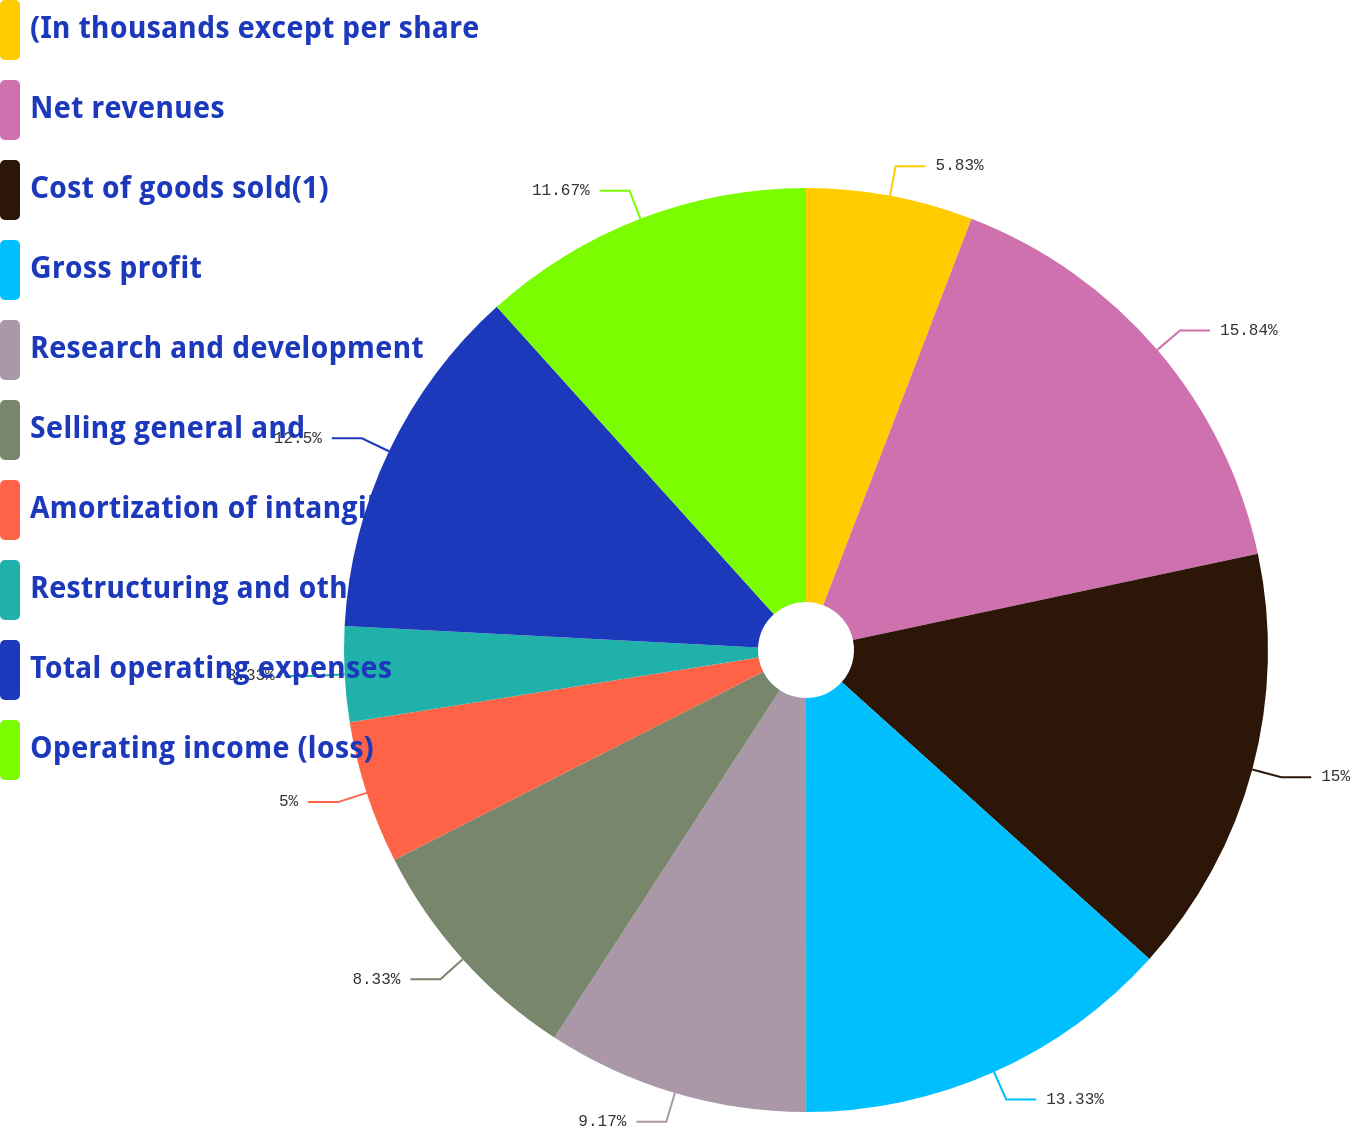Convert chart. <chart><loc_0><loc_0><loc_500><loc_500><pie_chart><fcel>(In thousands except per share<fcel>Net revenues<fcel>Cost of goods sold(1)<fcel>Gross profit<fcel>Research and development<fcel>Selling general and<fcel>Amortization of intangible<fcel>Restructuring and other<fcel>Total operating expenses<fcel>Operating income (loss)<nl><fcel>5.83%<fcel>15.83%<fcel>15.0%<fcel>13.33%<fcel>9.17%<fcel>8.33%<fcel>5.0%<fcel>3.33%<fcel>12.5%<fcel>11.67%<nl></chart> 